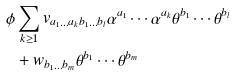<formula> <loc_0><loc_0><loc_500><loc_500>\phi & \sum _ { k \geq 1 } v _ { a _ { 1 } \dots a _ { k } b _ { 1 } \dots b _ { l } } \alpha ^ { a _ { 1 } } \cdots \alpha ^ { a _ { k } } \theta ^ { b _ { 1 } } \cdots \theta ^ { b _ { l } } \\ & + w _ { b _ { 1 } \dots b _ { m } } \theta ^ { b _ { 1 } } \cdots \theta ^ { b _ { m } }</formula> 